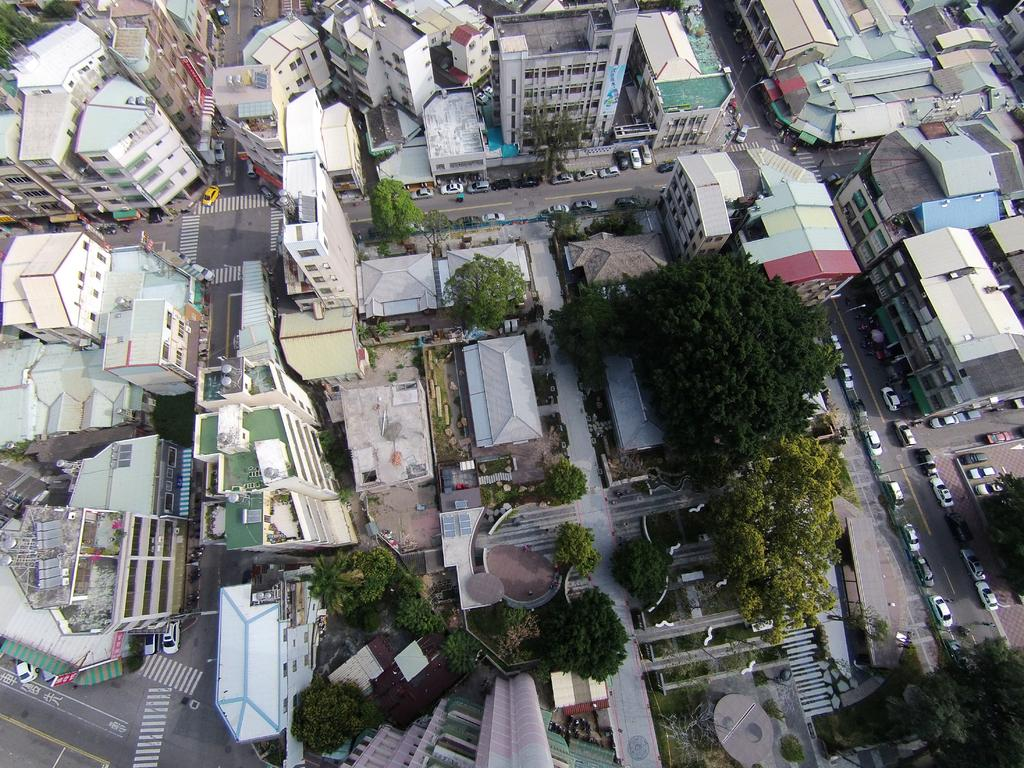What perspective is the image taken from? The image is taken from a top view. What type of natural elements can be seen in the image? There are trees in the image. What type of man-made structures are visible in the image? There are buildings in the image. What type of vehicles can be seen in the image? There are cars in the image. What type of scent can be detected from the image? There is no scent present in the image, as it is a visual representation. 